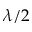Convert formula to latex. <formula><loc_0><loc_0><loc_500><loc_500>\lambda / 2</formula> 